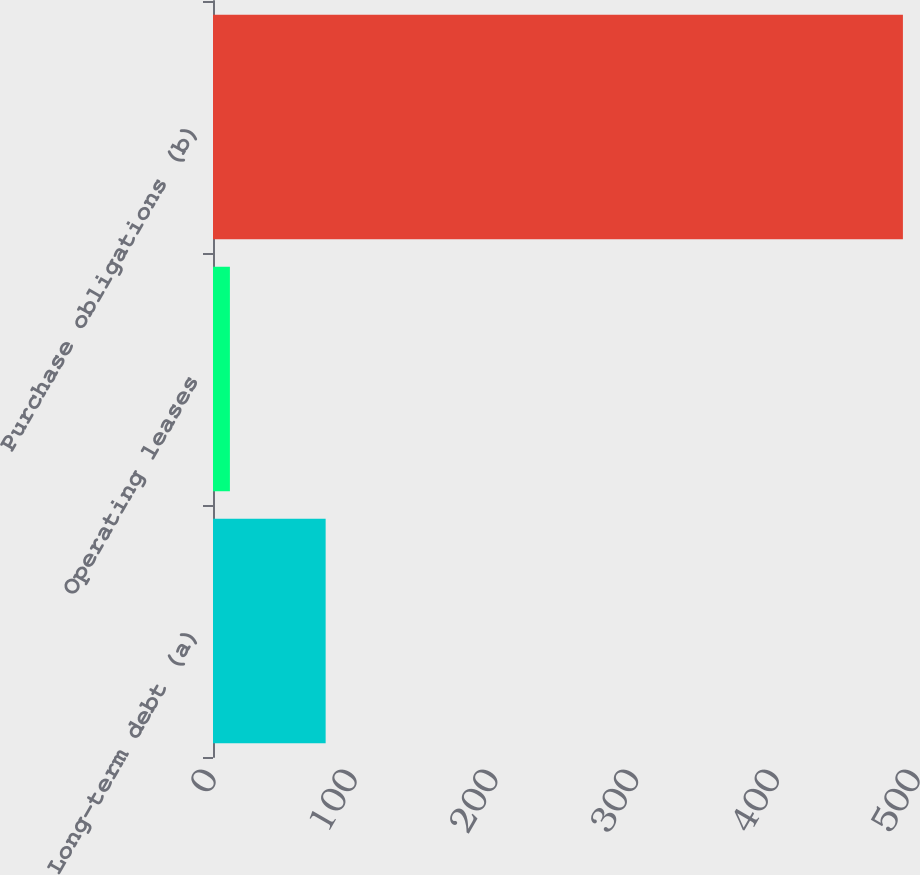Convert chart to OTSL. <chart><loc_0><loc_0><loc_500><loc_500><bar_chart><fcel>Long-term debt (a)<fcel>Operating leases<fcel>Purchase obligations (b)<nl><fcel>80<fcel>12<fcel>490<nl></chart> 